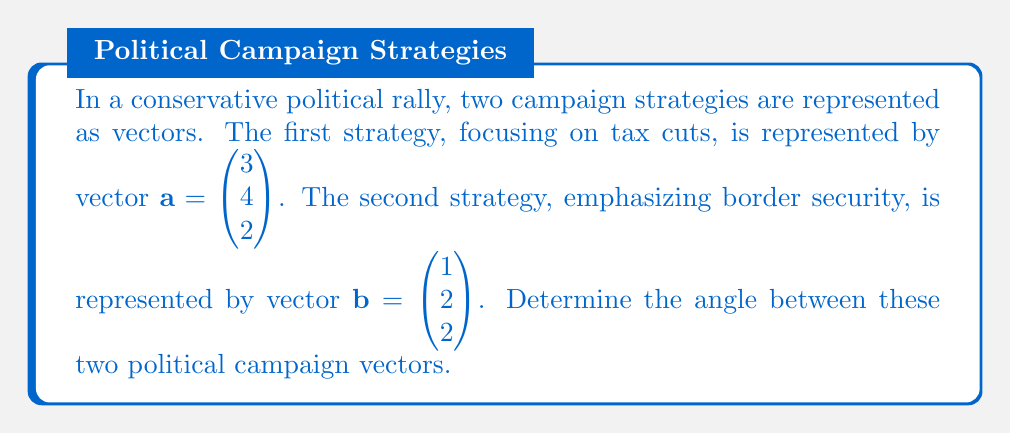Provide a solution to this math problem. To find the angle between two vectors, we can use the dot product formula:

$$\cos \theta = \frac{\mathbf{a} \cdot \mathbf{b}}{|\mathbf{a}||\mathbf{b}|}$$

Where $\theta$ is the angle between the vectors, $\mathbf{a} \cdot \mathbf{b}$ is the dot product of the vectors, and $|\mathbf{a}|$ and $|\mathbf{b}|$ are the magnitudes of vectors $\mathbf{a}$ and $\mathbf{b}$ respectively.

Step 1: Calculate the dot product $\mathbf{a} \cdot \mathbf{b}$
$$\mathbf{a} \cdot \mathbf{b} = (3)(1) + (4)(2) + (2)(2) = 3 + 8 + 4 = 15$$

Step 2: Calculate the magnitudes of $\mathbf{a}$ and $\mathbf{b}$
$$|\mathbf{a}| = \sqrt{3^2 + 4^2 + 2^2} = \sqrt{9 + 16 + 4} = \sqrt{29}$$
$$|\mathbf{b}| = \sqrt{1^2 + 2^2 + 2^2} = \sqrt{1 + 4 + 4} = 3$$

Step 3: Substitute into the formula
$$\cos \theta = \frac{15}{\sqrt{29} \cdot 3}$$

Step 4: Simplify
$$\cos \theta = \frac{15}{3\sqrt{29}} = \frac{5}{\sqrt{29}}$$

Step 5: Take the inverse cosine (arccos) of both sides
$$\theta = \arccos\left(\frac{5}{\sqrt{29}}\right)$$

Step 6: Calculate the final result (in radians)
$$\theta \approx 0.5808 \text{ radians}$$

Step 7: Convert to degrees
$$\theta \approx 33.28°$$
Answer: The angle between the two political campaign vectors is approximately 33.28°. 